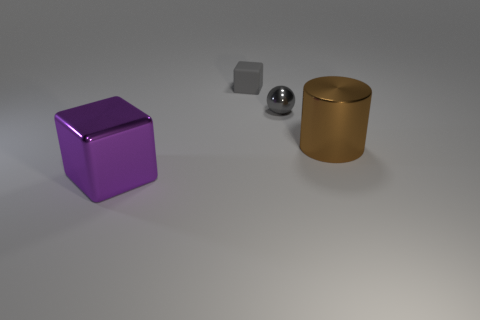What is the material of the thing that is in front of the gray shiny thing and on the right side of the metal cube?
Ensure brevity in your answer.  Metal. There is another big object that is the same shape as the rubber object; what is its material?
Provide a succinct answer. Metal. What number of cubes are large cyan things or big metallic things?
Ensure brevity in your answer.  1. There is a object that is behind the gray thing that is in front of the matte object; what is its size?
Offer a very short reply. Small. Is the color of the large metal block the same as the metallic thing that is behind the big cylinder?
Offer a terse response. No. There is a ball; what number of brown objects are behind it?
Your response must be concise. 0. Is the number of large red shiny objects less than the number of small spheres?
Offer a terse response. Yes. How big is the object that is both right of the tiny gray cube and to the left of the brown metallic object?
Make the answer very short. Small. There is a tiny thing that is behind the small shiny object; does it have the same color as the ball?
Offer a very short reply. Yes. Are there fewer small gray matte blocks right of the big brown shiny object than small matte things?
Provide a short and direct response. Yes. 